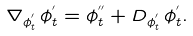<formula> <loc_0><loc_0><loc_500><loc_500>\nabla _ { \phi ^ { ^ { \prime } } _ { t } } \, { \phi ^ { ^ { \prime } } _ { t } } = \phi ^ { ^ { \prime \prime } } _ { t } + D _ { \phi ^ { ^ { \prime } } _ { t } } \, \phi ^ { ^ { \prime } } _ { t } .</formula> 